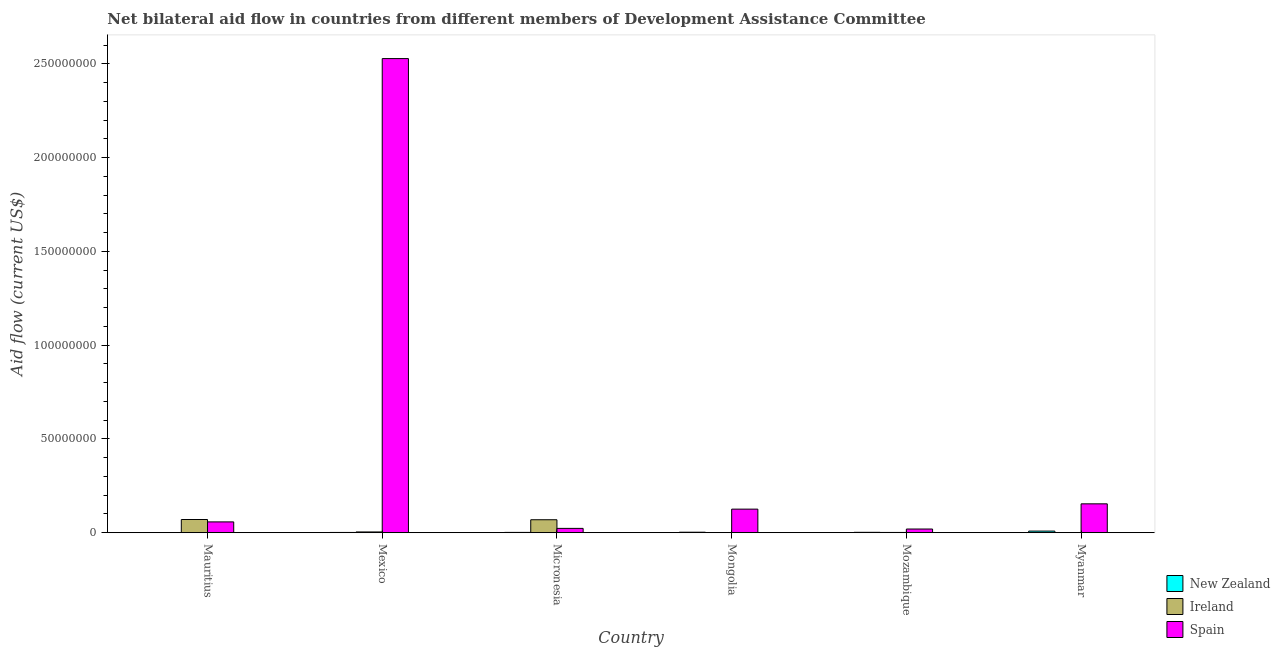How many groups of bars are there?
Offer a terse response. 6. Are the number of bars per tick equal to the number of legend labels?
Provide a succinct answer. Yes. How many bars are there on the 5th tick from the right?
Offer a terse response. 3. What is the label of the 3rd group of bars from the left?
Keep it short and to the point. Micronesia. What is the amount of aid provided by spain in Myanmar?
Your response must be concise. 1.54e+07. Across all countries, what is the maximum amount of aid provided by spain?
Your answer should be very brief. 2.53e+08. Across all countries, what is the minimum amount of aid provided by spain?
Your answer should be very brief. 1.97e+06. In which country was the amount of aid provided by ireland maximum?
Provide a short and direct response. Mauritius. In which country was the amount of aid provided by ireland minimum?
Give a very brief answer. Mongolia. What is the total amount of aid provided by ireland in the graph?
Give a very brief answer. 1.46e+07. What is the difference between the amount of aid provided by spain in Micronesia and that in Mozambique?
Your response must be concise. 3.40e+05. What is the difference between the amount of aid provided by new zealand in Mauritius and the amount of aid provided by spain in Mongolia?
Give a very brief answer. -1.25e+07. What is the average amount of aid provided by ireland per country?
Give a very brief answer. 2.44e+06. What is the difference between the amount of aid provided by new zealand and amount of aid provided by spain in Myanmar?
Your answer should be very brief. -1.45e+07. What is the ratio of the amount of aid provided by new zealand in Mongolia to that in Mozambique?
Make the answer very short. 1.29. Is the amount of aid provided by spain in Mauritius less than that in Mozambique?
Offer a terse response. No. What is the difference between the highest and the second highest amount of aid provided by new zealand?
Give a very brief answer. 6.00e+05. What is the difference between the highest and the lowest amount of aid provided by ireland?
Provide a succinct answer. 7.00e+06. In how many countries, is the amount of aid provided by spain greater than the average amount of aid provided by spain taken over all countries?
Your answer should be very brief. 1. Is the sum of the amount of aid provided by new zealand in Mozambique and Myanmar greater than the maximum amount of aid provided by spain across all countries?
Make the answer very short. No. What does the 1st bar from the left in Mozambique represents?
Your answer should be compact. New Zealand. What does the 2nd bar from the right in Micronesia represents?
Your answer should be compact. Ireland. Is it the case that in every country, the sum of the amount of aid provided by new zealand and amount of aid provided by ireland is greater than the amount of aid provided by spain?
Provide a short and direct response. No. Are all the bars in the graph horizontal?
Your answer should be compact. No. How many legend labels are there?
Give a very brief answer. 3. What is the title of the graph?
Provide a short and direct response. Net bilateral aid flow in countries from different members of Development Assistance Committee. Does "Infant(male)" appear as one of the legend labels in the graph?
Offer a terse response. No. What is the label or title of the X-axis?
Offer a very short reply. Country. What is the label or title of the Y-axis?
Offer a terse response. Aid flow (current US$). What is the Aid flow (current US$) of New Zealand in Mauritius?
Offer a very short reply. 4.00e+04. What is the Aid flow (current US$) in Ireland in Mauritius?
Your answer should be compact. 7.04e+06. What is the Aid flow (current US$) of Spain in Mauritius?
Offer a terse response. 5.77e+06. What is the Aid flow (current US$) of Spain in Mexico?
Make the answer very short. 2.53e+08. What is the Aid flow (current US$) of Ireland in Micronesia?
Provide a short and direct response. 6.92e+06. What is the Aid flow (current US$) of Spain in Micronesia?
Provide a succinct answer. 2.31e+06. What is the Aid flow (current US$) of New Zealand in Mongolia?
Provide a short and direct response. 2.70e+05. What is the Aid flow (current US$) in Spain in Mongolia?
Ensure brevity in your answer.  1.26e+07. What is the Aid flow (current US$) of New Zealand in Mozambique?
Provide a succinct answer. 2.10e+05. What is the Aid flow (current US$) of Ireland in Mozambique?
Your answer should be very brief. 1.40e+05. What is the Aid flow (current US$) of Spain in Mozambique?
Offer a terse response. 1.97e+06. What is the Aid flow (current US$) in New Zealand in Myanmar?
Provide a short and direct response. 8.70e+05. What is the Aid flow (current US$) in Ireland in Myanmar?
Make the answer very short. 6.00e+04. What is the Aid flow (current US$) in Spain in Myanmar?
Offer a very short reply. 1.54e+07. Across all countries, what is the maximum Aid flow (current US$) of New Zealand?
Offer a terse response. 8.70e+05. Across all countries, what is the maximum Aid flow (current US$) of Ireland?
Give a very brief answer. 7.04e+06. Across all countries, what is the maximum Aid flow (current US$) of Spain?
Provide a short and direct response. 2.53e+08. Across all countries, what is the minimum Aid flow (current US$) of Ireland?
Provide a short and direct response. 4.00e+04. Across all countries, what is the minimum Aid flow (current US$) of Spain?
Give a very brief answer. 1.97e+06. What is the total Aid flow (current US$) in New Zealand in the graph?
Give a very brief answer. 1.70e+06. What is the total Aid flow (current US$) of Ireland in the graph?
Provide a short and direct response. 1.46e+07. What is the total Aid flow (current US$) of Spain in the graph?
Offer a terse response. 2.91e+08. What is the difference between the Aid flow (current US$) of New Zealand in Mauritius and that in Mexico?
Provide a succinct answer. -1.00e+05. What is the difference between the Aid flow (current US$) of Ireland in Mauritius and that in Mexico?
Offer a very short reply. 6.63e+06. What is the difference between the Aid flow (current US$) of Spain in Mauritius and that in Mexico?
Your response must be concise. -2.47e+08. What is the difference between the Aid flow (current US$) in New Zealand in Mauritius and that in Micronesia?
Your answer should be compact. -1.30e+05. What is the difference between the Aid flow (current US$) in Spain in Mauritius and that in Micronesia?
Ensure brevity in your answer.  3.46e+06. What is the difference between the Aid flow (current US$) of Ireland in Mauritius and that in Mongolia?
Your answer should be very brief. 7.00e+06. What is the difference between the Aid flow (current US$) of Spain in Mauritius and that in Mongolia?
Your answer should be very brief. -6.80e+06. What is the difference between the Aid flow (current US$) of Ireland in Mauritius and that in Mozambique?
Make the answer very short. 6.90e+06. What is the difference between the Aid flow (current US$) in Spain in Mauritius and that in Mozambique?
Your answer should be compact. 3.80e+06. What is the difference between the Aid flow (current US$) in New Zealand in Mauritius and that in Myanmar?
Ensure brevity in your answer.  -8.30e+05. What is the difference between the Aid flow (current US$) in Ireland in Mauritius and that in Myanmar?
Offer a terse response. 6.98e+06. What is the difference between the Aid flow (current US$) in Spain in Mauritius and that in Myanmar?
Give a very brief answer. -9.63e+06. What is the difference between the Aid flow (current US$) of Ireland in Mexico and that in Micronesia?
Your answer should be compact. -6.51e+06. What is the difference between the Aid flow (current US$) of Spain in Mexico and that in Micronesia?
Provide a short and direct response. 2.51e+08. What is the difference between the Aid flow (current US$) of New Zealand in Mexico and that in Mongolia?
Offer a very short reply. -1.30e+05. What is the difference between the Aid flow (current US$) of Spain in Mexico and that in Mongolia?
Your response must be concise. 2.40e+08. What is the difference between the Aid flow (current US$) in New Zealand in Mexico and that in Mozambique?
Your answer should be compact. -7.00e+04. What is the difference between the Aid flow (current US$) of Ireland in Mexico and that in Mozambique?
Provide a short and direct response. 2.70e+05. What is the difference between the Aid flow (current US$) of Spain in Mexico and that in Mozambique?
Your response must be concise. 2.51e+08. What is the difference between the Aid flow (current US$) in New Zealand in Mexico and that in Myanmar?
Provide a succinct answer. -7.30e+05. What is the difference between the Aid flow (current US$) of Spain in Mexico and that in Myanmar?
Provide a succinct answer. 2.37e+08. What is the difference between the Aid flow (current US$) in New Zealand in Micronesia and that in Mongolia?
Offer a very short reply. -1.00e+05. What is the difference between the Aid flow (current US$) in Ireland in Micronesia and that in Mongolia?
Provide a short and direct response. 6.88e+06. What is the difference between the Aid flow (current US$) in Spain in Micronesia and that in Mongolia?
Give a very brief answer. -1.03e+07. What is the difference between the Aid flow (current US$) of Ireland in Micronesia and that in Mozambique?
Ensure brevity in your answer.  6.78e+06. What is the difference between the Aid flow (current US$) of New Zealand in Micronesia and that in Myanmar?
Give a very brief answer. -7.00e+05. What is the difference between the Aid flow (current US$) in Ireland in Micronesia and that in Myanmar?
Your response must be concise. 6.86e+06. What is the difference between the Aid flow (current US$) of Spain in Micronesia and that in Myanmar?
Make the answer very short. -1.31e+07. What is the difference between the Aid flow (current US$) of New Zealand in Mongolia and that in Mozambique?
Keep it short and to the point. 6.00e+04. What is the difference between the Aid flow (current US$) of Spain in Mongolia and that in Mozambique?
Keep it short and to the point. 1.06e+07. What is the difference between the Aid flow (current US$) of New Zealand in Mongolia and that in Myanmar?
Make the answer very short. -6.00e+05. What is the difference between the Aid flow (current US$) in Spain in Mongolia and that in Myanmar?
Ensure brevity in your answer.  -2.83e+06. What is the difference between the Aid flow (current US$) in New Zealand in Mozambique and that in Myanmar?
Ensure brevity in your answer.  -6.60e+05. What is the difference between the Aid flow (current US$) of Spain in Mozambique and that in Myanmar?
Offer a very short reply. -1.34e+07. What is the difference between the Aid flow (current US$) in New Zealand in Mauritius and the Aid flow (current US$) in Ireland in Mexico?
Offer a very short reply. -3.70e+05. What is the difference between the Aid flow (current US$) of New Zealand in Mauritius and the Aid flow (current US$) of Spain in Mexico?
Your answer should be compact. -2.53e+08. What is the difference between the Aid flow (current US$) of Ireland in Mauritius and the Aid flow (current US$) of Spain in Mexico?
Your response must be concise. -2.46e+08. What is the difference between the Aid flow (current US$) in New Zealand in Mauritius and the Aid flow (current US$) in Ireland in Micronesia?
Your response must be concise. -6.88e+06. What is the difference between the Aid flow (current US$) of New Zealand in Mauritius and the Aid flow (current US$) of Spain in Micronesia?
Your answer should be compact. -2.27e+06. What is the difference between the Aid flow (current US$) of Ireland in Mauritius and the Aid flow (current US$) of Spain in Micronesia?
Provide a short and direct response. 4.73e+06. What is the difference between the Aid flow (current US$) of New Zealand in Mauritius and the Aid flow (current US$) of Spain in Mongolia?
Keep it short and to the point. -1.25e+07. What is the difference between the Aid flow (current US$) of Ireland in Mauritius and the Aid flow (current US$) of Spain in Mongolia?
Give a very brief answer. -5.53e+06. What is the difference between the Aid flow (current US$) of New Zealand in Mauritius and the Aid flow (current US$) of Spain in Mozambique?
Keep it short and to the point. -1.93e+06. What is the difference between the Aid flow (current US$) of Ireland in Mauritius and the Aid flow (current US$) of Spain in Mozambique?
Provide a short and direct response. 5.07e+06. What is the difference between the Aid flow (current US$) of New Zealand in Mauritius and the Aid flow (current US$) of Spain in Myanmar?
Provide a succinct answer. -1.54e+07. What is the difference between the Aid flow (current US$) in Ireland in Mauritius and the Aid flow (current US$) in Spain in Myanmar?
Offer a terse response. -8.36e+06. What is the difference between the Aid flow (current US$) in New Zealand in Mexico and the Aid flow (current US$) in Ireland in Micronesia?
Provide a short and direct response. -6.78e+06. What is the difference between the Aid flow (current US$) in New Zealand in Mexico and the Aid flow (current US$) in Spain in Micronesia?
Give a very brief answer. -2.17e+06. What is the difference between the Aid flow (current US$) in Ireland in Mexico and the Aid flow (current US$) in Spain in Micronesia?
Your response must be concise. -1.90e+06. What is the difference between the Aid flow (current US$) in New Zealand in Mexico and the Aid flow (current US$) in Spain in Mongolia?
Keep it short and to the point. -1.24e+07. What is the difference between the Aid flow (current US$) in Ireland in Mexico and the Aid flow (current US$) in Spain in Mongolia?
Provide a short and direct response. -1.22e+07. What is the difference between the Aid flow (current US$) in New Zealand in Mexico and the Aid flow (current US$) in Ireland in Mozambique?
Give a very brief answer. 0. What is the difference between the Aid flow (current US$) in New Zealand in Mexico and the Aid flow (current US$) in Spain in Mozambique?
Your answer should be compact. -1.83e+06. What is the difference between the Aid flow (current US$) in Ireland in Mexico and the Aid flow (current US$) in Spain in Mozambique?
Give a very brief answer. -1.56e+06. What is the difference between the Aid flow (current US$) in New Zealand in Mexico and the Aid flow (current US$) in Ireland in Myanmar?
Offer a terse response. 8.00e+04. What is the difference between the Aid flow (current US$) of New Zealand in Mexico and the Aid flow (current US$) of Spain in Myanmar?
Offer a very short reply. -1.53e+07. What is the difference between the Aid flow (current US$) of Ireland in Mexico and the Aid flow (current US$) of Spain in Myanmar?
Your answer should be very brief. -1.50e+07. What is the difference between the Aid flow (current US$) of New Zealand in Micronesia and the Aid flow (current US$) of Spain in Mongolia?
Offer a very short reply. -1.24e+07. What is the difference between the Aid flow (current US$) of Ireland in Micronesia and the Aid flow (current US$) of Spain in Mongolia?
Ensure brevity in your answer.  -5.65e+06. What is the difference between the Aid flow (current US$) of New Zealand in Micronesia and the Aid flow (current US$) of Ireland in Mozambique?
Make the answer very short. 3.00e+04. What is the difference between the Aid flow (current US$) in New Zealand in Micronesia and the Aid flow (current US$) in Spain in Mozambique?
Ensure brevity in your answer.  -1.80e+06. What is the difference between the Aid flow (current US$) of Ireland in Micronesia and the Aid flow (current US$) of Spain in Mozambique?
Your answer should be very brief. 4.95e+06. What is the difference between the Aid flow (current US$) of New Zealand in Micronesia and the Aid flow (current US$) of Spain in Myanmar?
Give a very brief answer. -1.52e+07. What is the difference between the Aid flow (current US$) in Ireland in Micronesia and the Aid flow (current US$) in Spain in Myanmar?
Your answer should be compact. -8.48e+06. What is the difference between the Aid flow (current US$) in New Zealand in Mongolia and the Aid flow (current US$) in Ireland in Mozambique?
Give a very brief answer. 1.30e+05. What is the difference between the Aid flow (current US$) of New Zealand in Mongolia and the Aid flow (current US$) of Spain in Mozambique?
Your answer should be compact. -1.70e+06. What is the difference between the Aid flow (current US$) of Ireland in Mongolia and the Aid flow (current US$) of Spain in Mozambique?
Give a very brief answer. -1.93e+06. What is the difference between the Aid flow (current US$) in New Zealand in Mongolia and the Aid flow (current US$) in Spain in Myanmar?
Offer a terse response. -1.51e+07. What is the difference between the Aid flow (current US$) of Ireland in Mongolia and the Aid flow (current US$) of Spain in Myanmar?
Your answer should be compact. -1.54e+07. What is the difference between the Aid flow (current US$) in New Zealand in Mozambique and the Aid flow (current US$) in Ireland in Myanmar?
Make the answer very short. 1.50e+05. What is the difference between the Aid flow (current US$) of New Zealand in Mozambique and the Aid flow (current US$) of Spain in Myanmar?
Offer a very short reply. -1.52e+07. What is the difference between the Aid flow (current US$) in Ireland in Mozambique and the Aid flow (current US$) in Spain in Myanmar?
Your response must be concise. -1.53e+07. What is the average Aid flow (current US$) in New Zealand per country?
Your answer should be very brief. 2.83e+05. What is the average Aid flow (current US$) of Ireland per country?
Your answer should be compact. 2.44e+06. What is the average Aid flow (current US$) in Spain per country?
Give a very brief answer. 4.85e+07. What is the difference between the Aid flow (current US$) in New Zealand and Aid flow (current US$) in Ireland in Mauritius?
Your answer should be compact. -7.00e+06. What is the difference between the Aid flow (current US$) in New Zealand and Aid flow (current US$) in Spain in Mauritius?
Make the answer very short. -5.73e+06. What is the difference between the Aid flow (current US$) in Ireland and Aid flow (current US$) in Spain in Mauritius?
Your answer should be compact. 1.27e+06. What is the difference between the Aid flow (current US$) in New Zealand and Aid flow (current US$) in Ireland in Mexico?
Your response must be concise. -2.70e+05. What is the difference between the Aid flow (current US$) of New Zealand and Aid flow (current US$) of Spain in Mexico?
Your response must be concise. -2.53e+08. What is the difference between the Aid flow (current US$) in Ireland and Aid flow (current US$) in Spain in Mexico?
Give a very brief answer. -2.52e+08. What is the difference between the Aid flow (current US$) in New Zealand and Aid flow (current US$) in Ireland in Micronesia?
Provide a succinct answer. -6.75e+06. What is the difference between the Aid flow (current US$) of New Zealand and Aid flow (current US$) of Spain in Micronesia?
Your response must be concise. -2.14e+06. What is the difference between the Aid flow (current US$) in Ireland and Aid flow (current US$) in Spain in Micronesia?
Give a very brief answer. 4.61e+06. What is the difference between the Aid flow (current US$) of New Zealand and Aid flow (current US$) of Ireland in Mongolia?
Ensure brevity in your answer.  2.30e+05. What is the difference between the Aid flow (current US$) of New Zealand and Aid flow (current US$) of Spain in Mongolia?
Provide a succinct answer. -1.23e+07. What is the difference between the Aid flow (current US$) in Ireland and Aid flow (current US$) in Spain in Mongolia?
Offer a very short reply. -1.25e+07. What is the difference between the Aid flow (current US$) in New Zealand and Aid flow (current US$) in Ireland in Mozambique?
Provide a short and direct response. 7.00e+04. What is the difference between the Aid flow (current US$) in New Zealand and Aid flow (current US$) in Spain in Mozambique?
Offer a very short reply. -1.76e+06. What is the difference between the Aid flow (current US$) of Ireland and Aid flow (current US$) of Spain in Mozambique?
Offer a terse response. -1.83e+06. What is the difference between the Aid flow (current US$) in New Zealand and Aid flow (current US$) in Ireland in Myanmar?
Offer a terse response. 8.10e+05. What is the difference between the Aid flow (current US$) in New Zealand and Aid flow (current US$) in Spain in Myanmar?
Your answer should be compact. -1.45e+07. What is the difference between the Aid flow (current US$) in Ireland and Aid flow (current US$) in Spain in Myanmar?
Make the answer very short. -1.53e+07. What is the ratio of the Aid flow (current US$) in New Zealand in Mauritius to that in Mexico?
Make the answer very short. 0.29. What is the ratio of the Aid flow (current US$) of Ireland in Mauritius to that in Mexico?
Make the answer very short. 17.17. What is the ratio of the Aid flow (current US$) in Spain in Mauritius to that in Mexico?
Provide a succinct answer. 0.02. What is the ratio of the Aid flow (current US$) in New Zealand in Mauritius to that in Micronesia?
Your answer should be very brief. 0.24. What is the ratio of the Aid flow (current US$) of Ireland in Mauritius to that in Micronesia?
Provide a succinct answer. 1.02. What is the ratio of the Aid flow (current US$) of Spain in Mauritius to that in Micronesia?
Keep it short and to the point. 2.5. What is the ratio of the Aid flow (current US$) in New Zealand in Mauritius to that in Mongolia?
Your response must be concise. 0.15. What is the ratio of the Aid flow (current US$) in Ireland in Mauritius to that in Mongolia?
Give a very brief answer. 176. What is the ratio of the Aid flow (current US$) in Spain in Mauritius to that in Mongolia?
Offer a terse response. 0.46. What is the ratio of the Aid flow (current US$) in New Zealand in Mauritius to that in Mozambique?
Give a very brief answer. 0.19. What is the ratio of the Aid flow (current US$) of Ireland in Mauritius to that in Mozambique?
Keep it short and to the point. 50.29. What is the ratio of the Aid flow (current US$) of Spain in Mauritius to that in Mozambique?
Make the answer very short. 2.93. What is the ratio of the Aid flow (current US$) of New Zealand in Mauritius to that in Myanmar?
Offer a terse response. 0.05. What is the ratio of the Aid flow (current US$) in Ireland in Mauritius to that in Myanmar?
Your response must be concise. 117.33. What is the ratio of the Aid flow (current US$) in Spain in Mauritius to that in Myanmar?
Give a very brief answer. 0.37. What is the ratio of the Aid flow (current US$) in New Zealand in Mexico to that in Micronesia?
Keep it short and to the point. 0.82. What is the ratio of the Aid flow (current US$) of Ireland in Mexico to that in Micronesia?
Your answer should be very brief. 0.06. What is the ratio of the Aid flow (current US$) in Spain in Mexico to that in Micronesia?
Give a very brief answer. 109.46. What is the ratio of the Aid flow (current US$) in New Zealand in Mexico to that in Mongolia?
Give a very brief answer. 0.52. What is the ratio of the Aid flow (current US$) of Ireland in Mexico to that in Mongolia?
Give a very brief answer. 10.25. What is the ratio of the Aid flow (current US$) of Spain in Mexico to that in Mongolia?
Offer a terse response. 20.12. What is the ratio of the Aid flow (current US$) in Ireland in Mexico to that in Mozambique?
Your response must be concise. 2.93. What is the ratio of the Aid flow (current US$) in Spain in Mexico to that in Mozambique?
Provide a short and direct response. 128.35. What is the ratio of the Aid flow (current US$) in New Zealand in Mexico to that in Myanmar?
Provide a succinct answer. 0.16. What is the ratio of the Aid flow (current US$) of Ireland in Mexico to that in Myanmar?
Keep it short and to the point. 6.83. What is the ratio of the Aid flow (current US$) of Spain in Mexico to that in Myanmar?
Offer a terse response. 16.42. What is the ratio of the Aid flow (current US$) in New Zealand in Micronesia to that in Mongolia?
Offer a terse response. 0.63. What is the ratio of the Aid flow (current US$) in Ireland in Micronesia to that in Mongolia?
Provide a short and direct response. 173. What is the ratio of the Aid flow (current US$) of Spain in Micronesia to that in Mongolia?
Offer a terse response. 0.18. What is the ratio of the Aid flow (current US$) in New Zealand in Micronesia to that in Mozambique?
Keep it short and to the point. 0.81. What is the ratio of the Aid flow (current US$) in Ireland in Micronesia to that in Mozambique?
Provide a short and direct response. 49.43. What is the ratio of the Aid flow (current US$) in Spain in Micronesia to that in Mozambique?
Make the answer very short. 1.17. What is the ratio of the Aid flow (current US$) of New Zealand in Micronesia to that in Myanmar?
Ensure brevity in your answer.  0.2. What is the ratio of the Aid flow (current US$) in Ireland in Micronesia to that in Myanmar?
Keep it short and to the point. 115.33. What is the ratio of the Aid flow (current US$) of Ireland in Mongolia to that in Mozambique?
Give a very brief answer. 0.29. What is the ratio of the Aid flow (current US$) of Spain in Mongolia to that in Mozambique?
Keep it short and to the point. 6.38. What is the ratio of the Aid flow (current US$) in New Zealand in Mongolia to that in Myanmar?
Provide a short and direct response. 0.31. What is the ratio of the Aid flow (current US$) in Spain in Mongolia to that in Myanmar?
Make the answer very short. 0.82. What is the ratio of the Aid flow (current US$) of New Zealand in Mozambique to that in Myanmar?
Provide a short and direct response. 0.24. What is the ratio of the Aid flow (current US$) of Ireland in Mozambique to that in Myanmar?
Give a very brief answer. 2.33. What is the ratio of the Aid flow (current US$) of Spain in Mozambique to that in Myanmar?
Offer a very short reply. 0.13. What is the difference between the highest and the second highest Aid flow (current US$) in Spain?
Offer a terse response. 2.37e+08. What is the difference between the highest and the lowest Aid flow (current US$) in New Zealand?
Your answer should be very brief. 8.30e+05. What is the difference between the highest and the lowest Aid flow (current US$) of Ireland?
Provide a short and direct response. 7.00e+06. What is the difference between the highest and the lowest Aid flow (current US$) of Spain?
Give a very brief answer. 2.51e+08. 